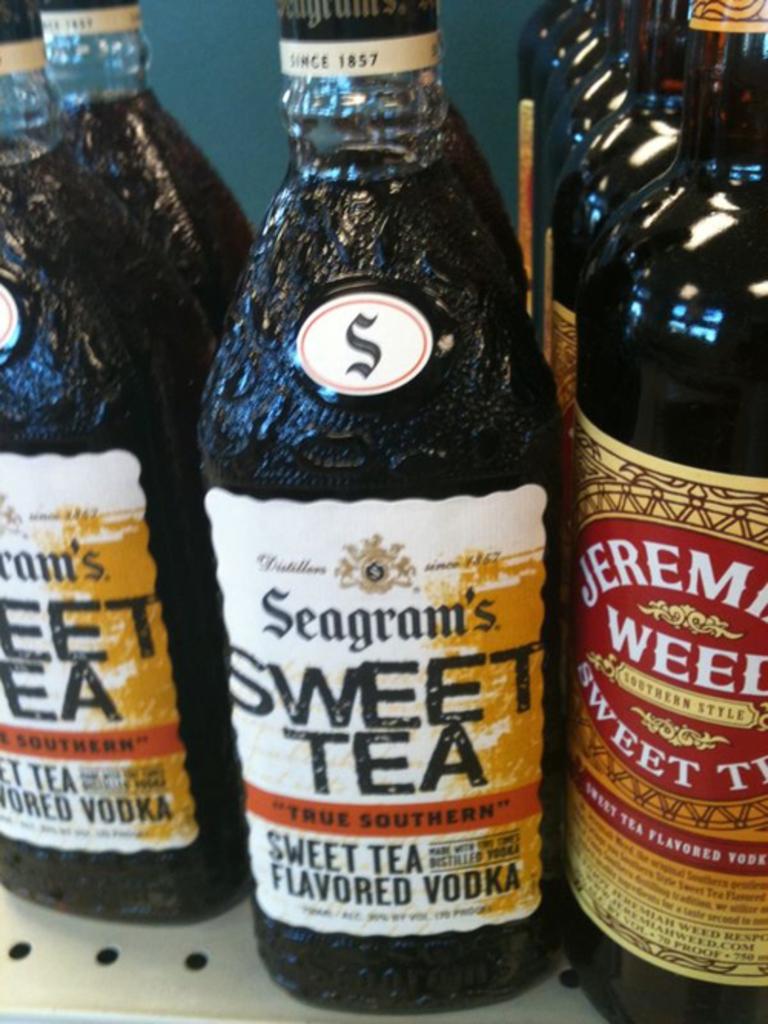Who makes this sweet tea vodka?
Your answer should be compact. Seagram's. 